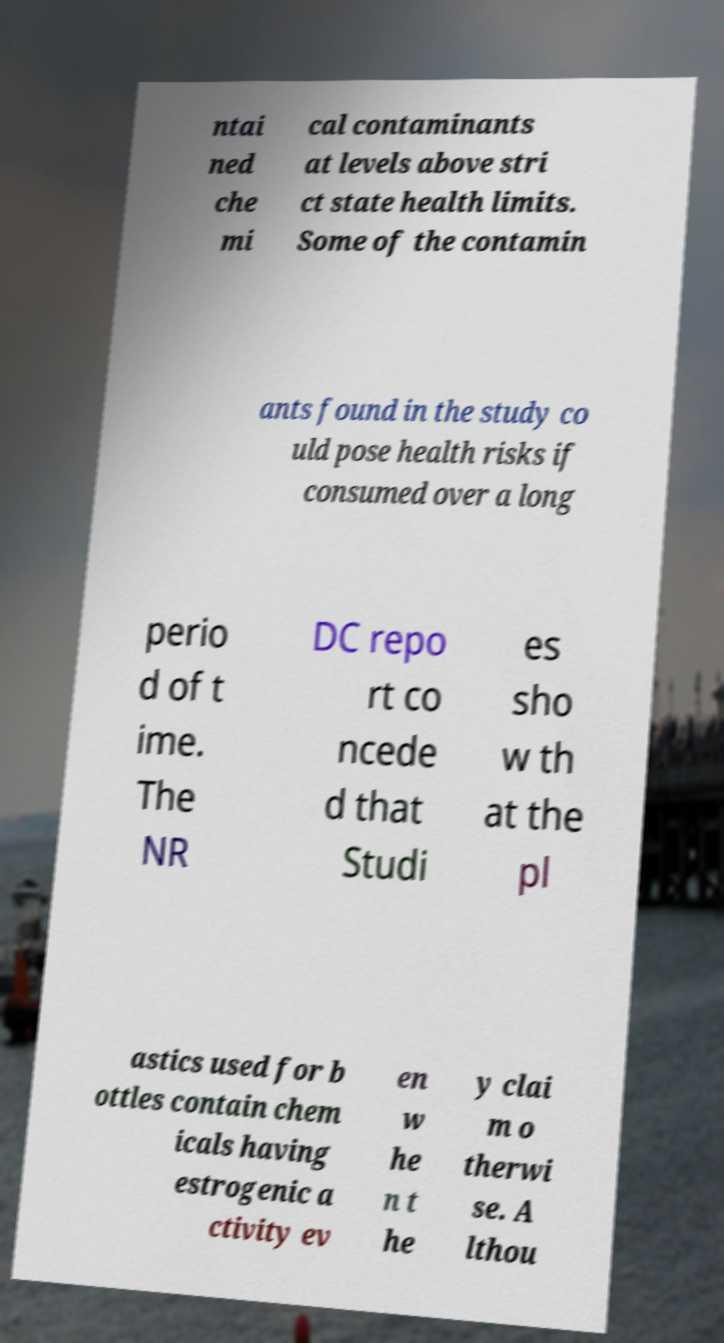Can you read and provide the text displayed in the image?This photo seems to have some interesting text. Can you extract and type it out for me? ntai ned che mi cal contaminants at levels above stri ct state health limits. Some of the contamin ants found in the study co uld pose health risks if consumed over a long perio d of t ime. The NR DC repo rt co ncede d that Studi es sho w th at the pl astics used for b ottles contain chem icals having estrogenic a ctivity ev en w he n t he y clai m o therwi se. A lthou 